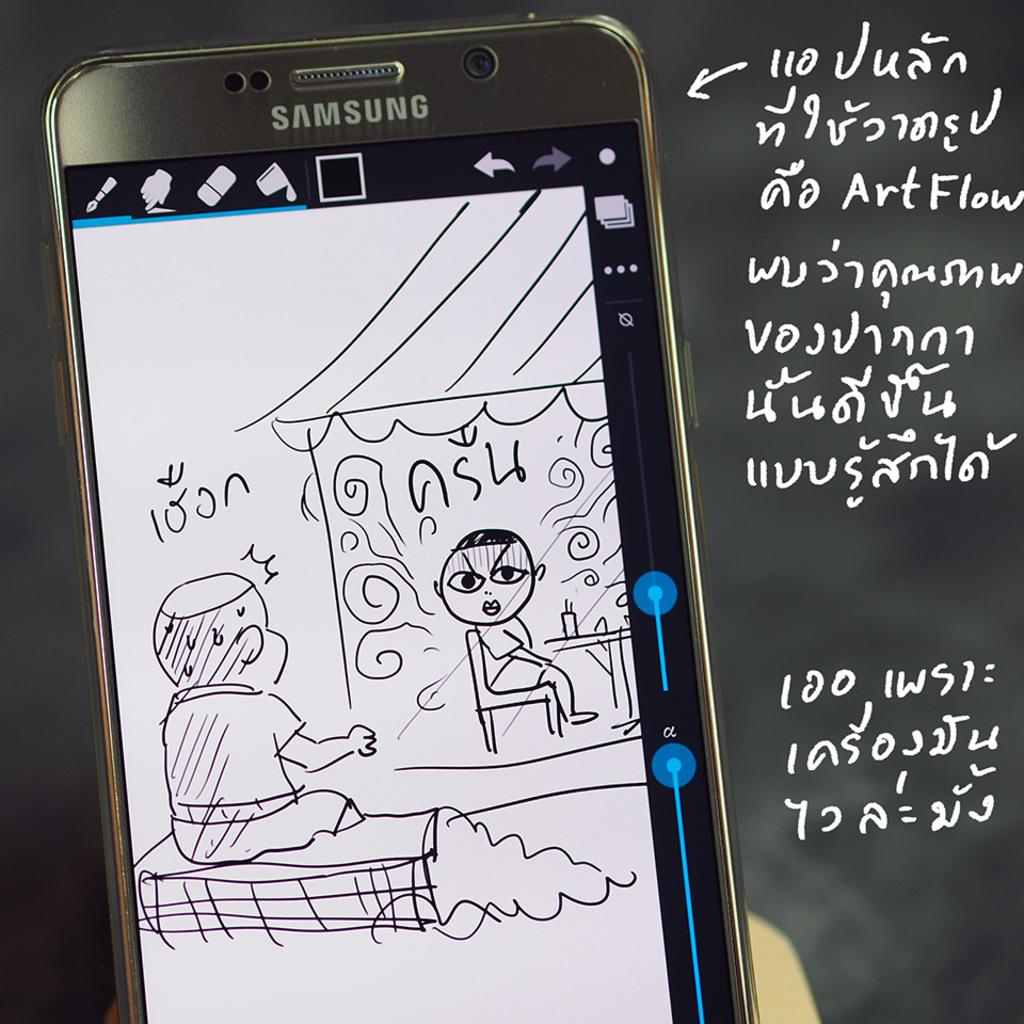Is this phone a samsung?
Make the answer very short. Yes. 